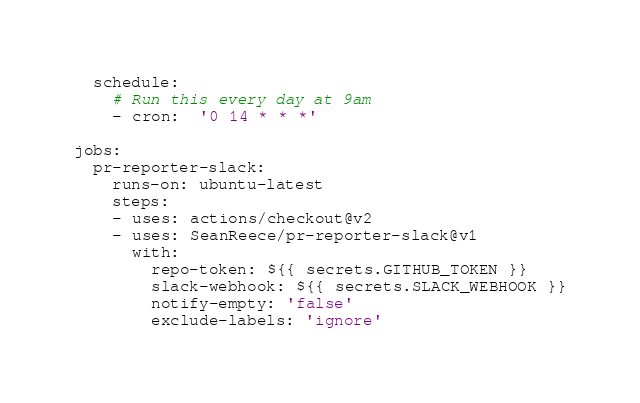Convert code to text. <code><loc_0><loc_0><loc_500><loc_500><_YAML_>  schedule:
    # Run this every day at 9am
    - cron:  '0 14 * * *'

jobs:
  pr-reporter-slack:
    runs-on: ubuntu-latest
    steps:
    - uses: actions/checkout@v2
    - uses: SeanReece/pr-reporter-slack@v1
      with: 
        repo-token: ${{ secrets.GITHUB_TOKEN }}
        slack-webhook: ${{ secrets.SLACK_WEBHOOK }}
        notify-empty: 'false'
        exclude-labels: 'ignore'
</code> 